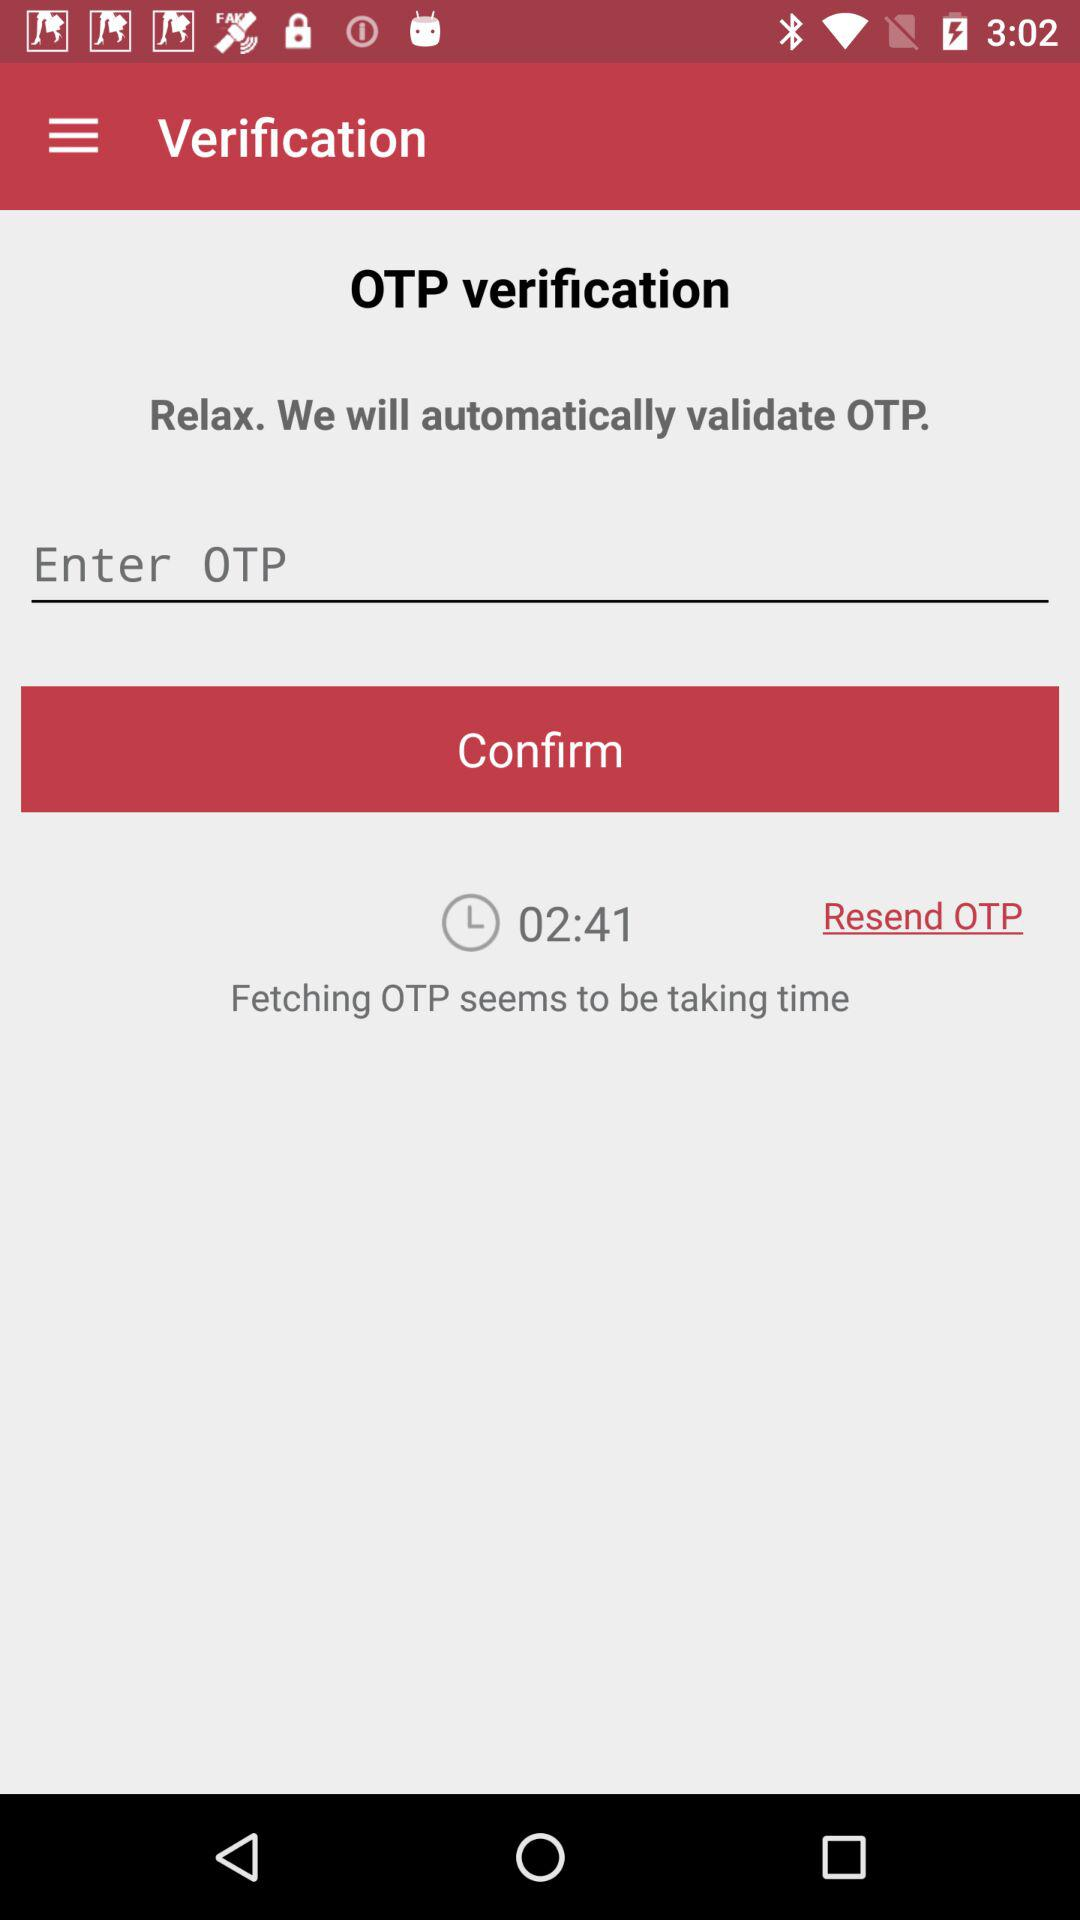How many numbers are in the OTP?
When the provided information is insufficient, respond with <no answer>. <no answer> 